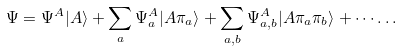Convert formula to latex. <formula><loc_0><loc_0><loc_500><loc_500>\Psi = \Psi ^ { A } | A \rangle + \sum _ { a } \Psi ^ { A } _ { a } | A \pi _ { a } \rangle + \sum _ { a , b } \Psi ^ { A } _ { a , b } | A \pi _ { a } \pi _ { b } \rangle + \cdots \dots</formula> 